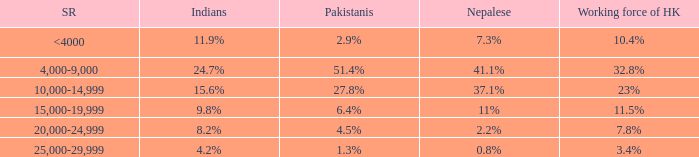If the Indians are 8.2%, what is the salary range? 20,000-24,999. 